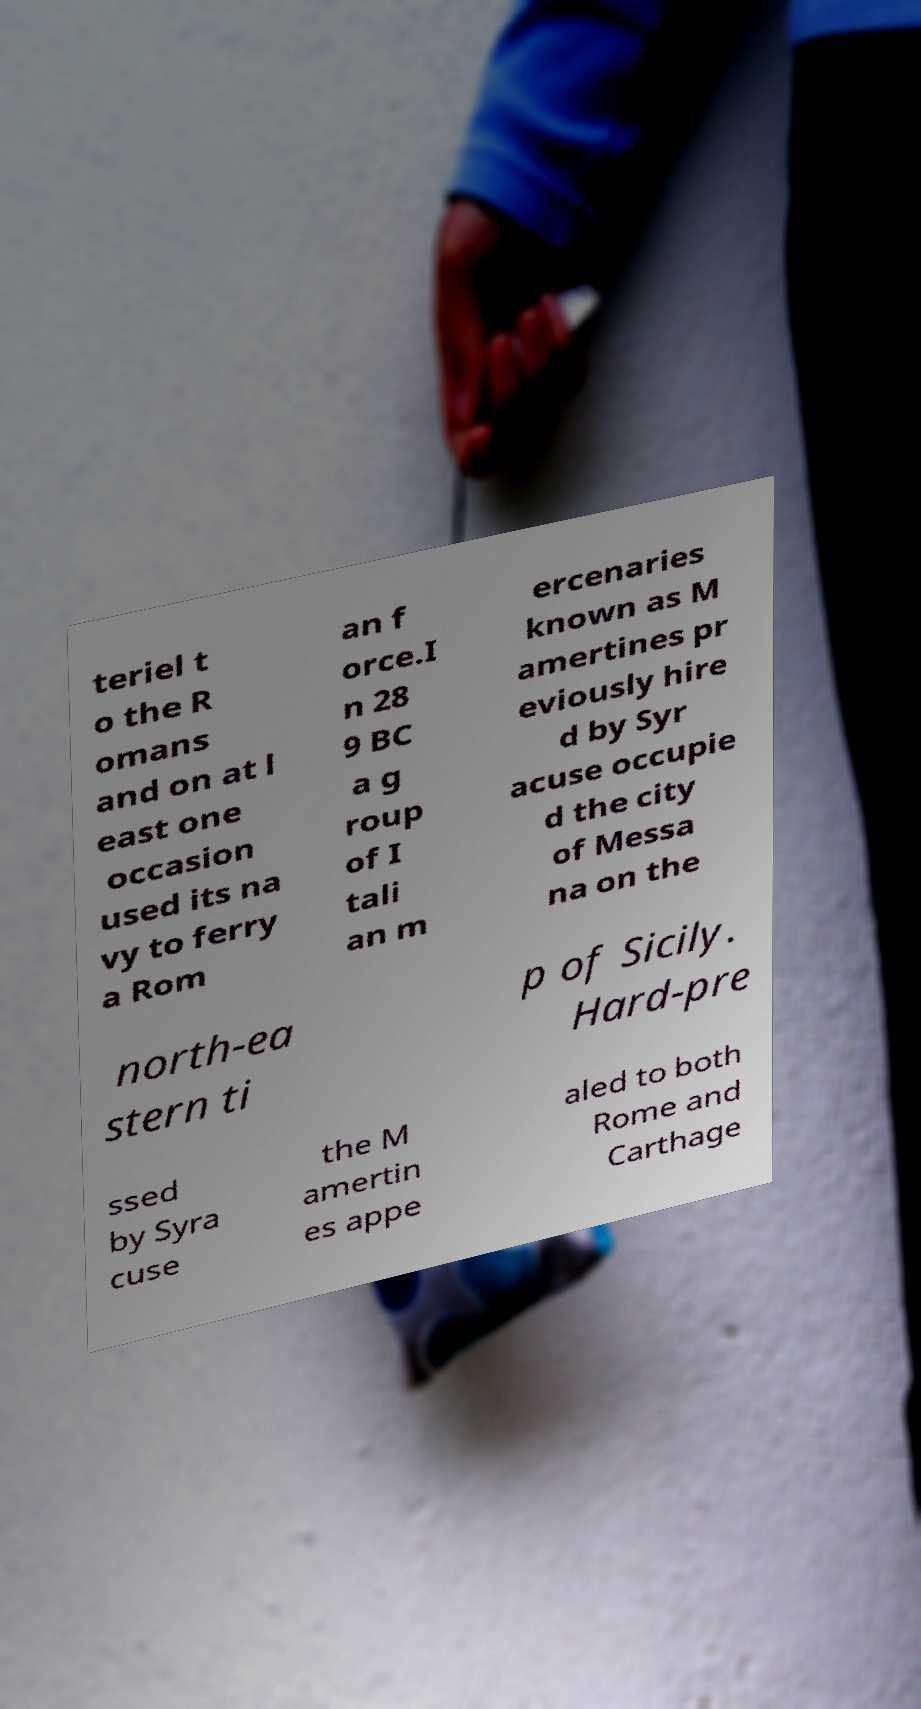What messages or text are displayed in this image? I need them in a readable, typed format. teriel t o the R omans and on at l east one occasion used its na vy to ferry a Rom an f orce.I n 28 9 BC a g roup of I tali an m ercenaries known as M amertines pr eviously hire d by Syr acuse occupie d the city of Messa na on the north-ea stern ti p of Sicily. Hard-pre ssed by Syra cuse the M amertin es appe aled to both Rome and Carthage 